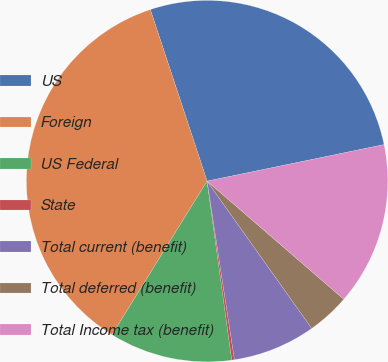Convert chart. <chart><loc_0><loc_0><loc_500><loc_500><pie_chart><fcel>US<fcel>Foreign<fcel>US Federal<fcel>State<fcel>Total current (benefit)<fcel>Total deferred (benefit)<fcel>Total Income tax (benefit)<nl><fcel>26.85%<fcel>36.1%<fcel>11.0%<fcel>0.24%<fcel>7.41%<fcel>3.83%<fcel>14.58%<nl></chart> 